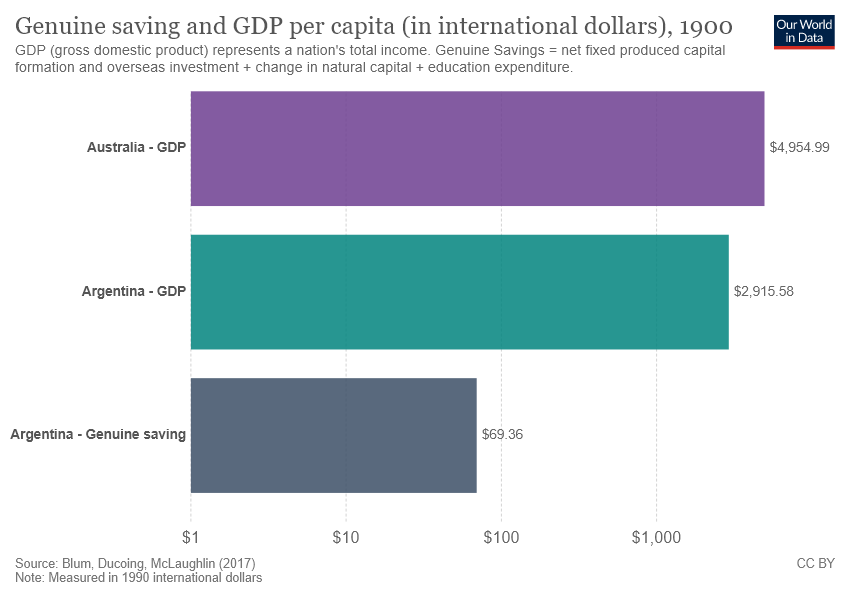Outline some significant characteristics in this image. The largest bar in the graph represents the Gross Domestic Product (GDP) of Australia. The sum of the smallest two bars is not greater than the largest bar. 